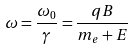<formula> <loc_0><loc_0><loc_500><loc_500>\omega = \frac { \omega _ { 0 } } { \gamma } = \frac { q B } { m _ { e } + E }</formula> 